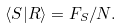<formula> <loc_0><loc_0><loc_500><loc_500>\langle S | R \rangle = F _ { S } / N .</formula> 